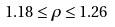<formula> <loc_0><loc_0><loc_500><loc_500>1 . 1 8 \leq \rho \leq 1 . 2 6</formula> 